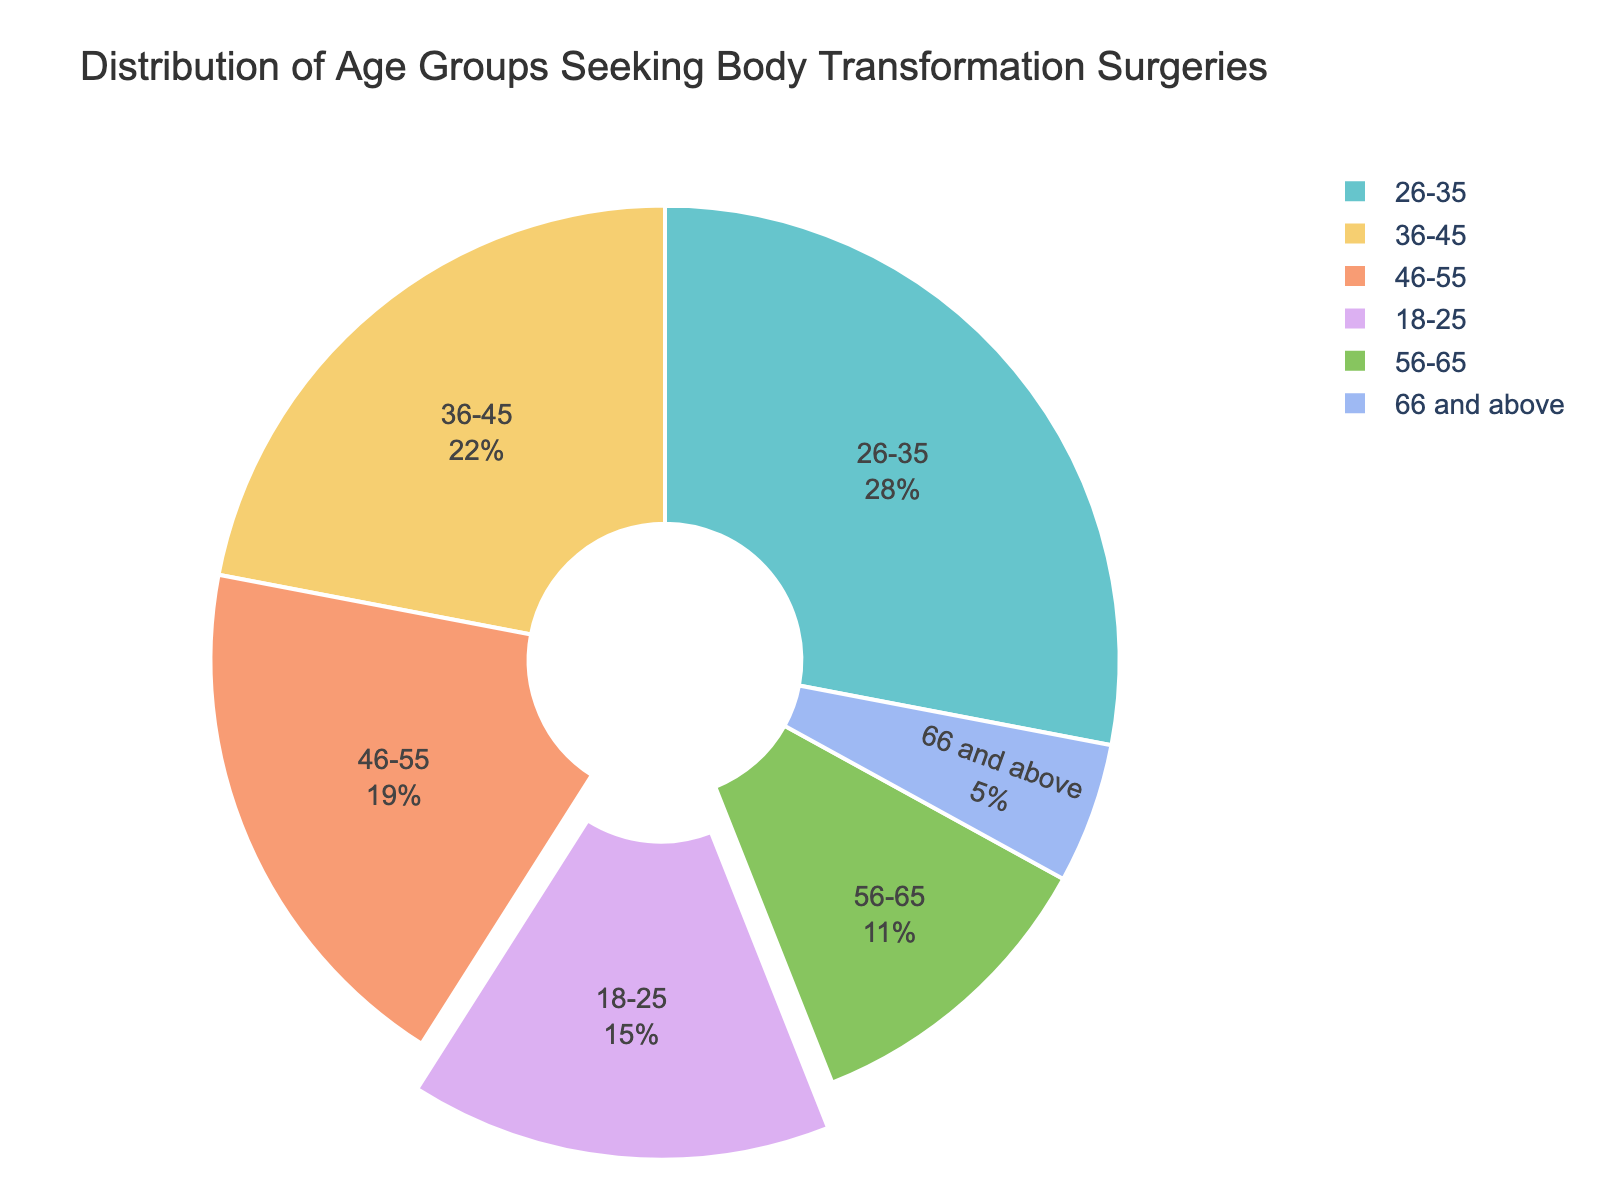What's the largest age group seeking body transformation surgeries? The slice representing the largest age group has the highest percentage value. According to the pie chart, the largest age group is 26-35 with 28%.
Answer: 26-35 What is the total percentage of people aged 36-55 seeking body transformation surgeries? Adding up the percentages for the age groups 36-45 and 46-55: 22% + 19% = 41%.
Answer: 41% Which age group has the smallest percentage of seekers? The smallest slice in the pie chart represents the age group with the smallest percentage. In this chart, the age group "66 and above" has the smallest percentage of 5%.
Answer: 66 and above How much larger is the percentage of the 26-35 age group compared to the 56-65 age group? Subtract the percentage of the 56-65 age group from the 26-35 age group: 28% - 11% = 17%.
Answer: 17% Compare the percentage of people aged 18-25 to those aged 46-55. Refer to the pie chart to observe the percentages. The 18-25 age group has 15% while the 46-55 age group has 19%. Thus, the 46-55 age group has a higher percentage.
Answer: 46-55 What percentage of people are 55 and under? Add up the percentages of all age groups 55 and under: 15% (18-25) + 28% (26-35) + 22% (36-45) + 19% (46-55) = 84%.
Answer: 84% What is the combined percentage of those aged 18-35? Add up the percentages for the age groups 18-25 and 26-35: 15% + 28% = 43%.
Answer: 43% Which color represents the age group 36-45 in the chart? Identify the segment with the percentage label "36-45" and note its color, which follows the color scheme used in the pie chart.
Answer: (Answer will vary, describing the visual color used) Is the percentage of the 26-35 age group greater than the combined percentage of the 56-65 and 66 and above age groups? Compare the percentage of the 26-35 group (28%) to the sum of the 56-65 and 66 and above groups: 11% + 5% = 16%. Yes, 28% is greater than 16%.
Answer: Yes Which age group occupies the second smallest portion of the pie chart? Excluding the smallest slice first, observe the next smallest slice. The second smallest portion is represented by the 56-65 age group with 11%.
Answer: 56-65 